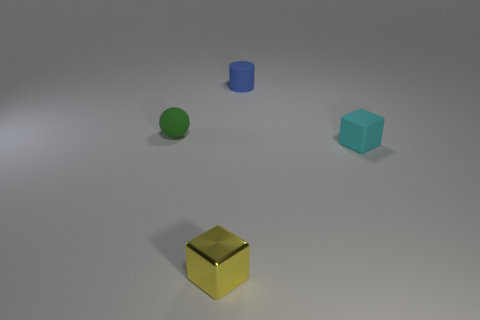Add 3 small yellow metallic cubes. How many objects exist? 7 Add 1 small green rubber spheres. How many small green rubber spheres are left? 2 Add 3 red blocks. How many red blocks exist? 3 Subtract 0 purple spheres. How many objects are left? 4 Subtract all balls. Subtract all small yellow metallic cubes. How many objects are left? 2 